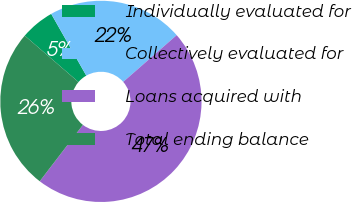Convert chart. <chart><loc_0><loc_0><loc_500><loc_500><pie_chart><fcel>Individually evaluated for<fcel>Collectively evaluated for<fcel>Loans acquired with<fcel>Total ending balance<nl><fcel>5.45%<fcel>21.79%<fcel>46.84%<fcel>25.93%<nl></chart> 